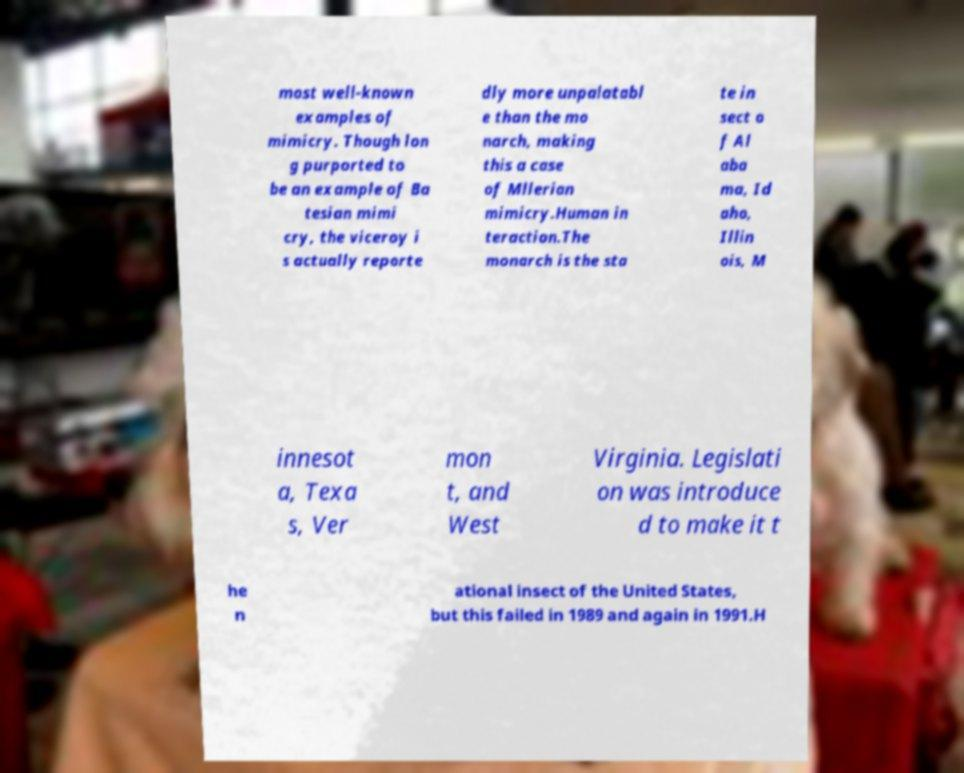Could you extract and type out the text from this image? most well-known examples of mimicry. Though lon g purported to be an example of Ba tesian mimi cry, the viceroy i s actually reporte dly more unpalatabl e than the mo narch, making this a case of Mllerian mimicry.Human in teraction.The monarch is the sta te in sect o f Al aba ma, Id aho, Illin ois, M innesot a, Texa s, Ver mon t, and West Virginia. Legislati on was introduce d to make it t he n ational insect of the United States, but this failed in 1989 and again in 1991.H 